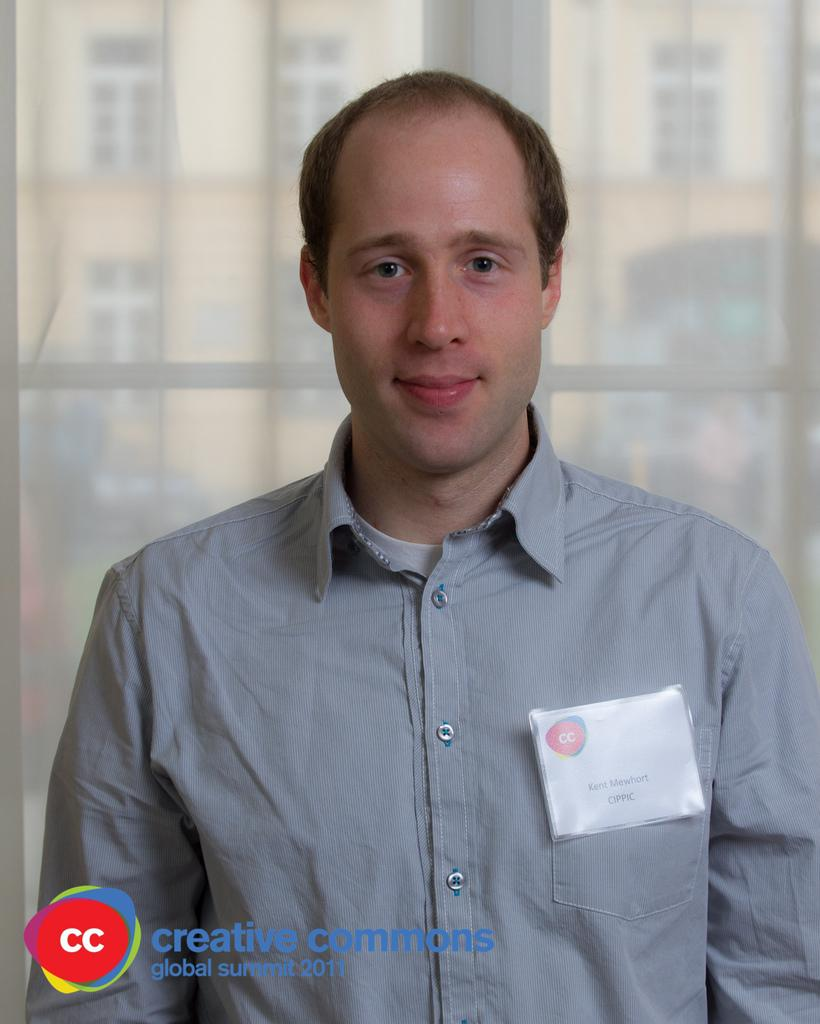What is present in the image? There is a man in the image. Can you describe the man's attire? The man is wearing a badge. What can be seen in the background of the image? There is a window with a curtain, and a building with windows is visible through the window. Is there any additional detail about the image itself? Yes, there is a watermark in the image. What type of scent can be detected from the secretary in the image? There is no secretary present in the image, and therefore no scent can be detected from one. 